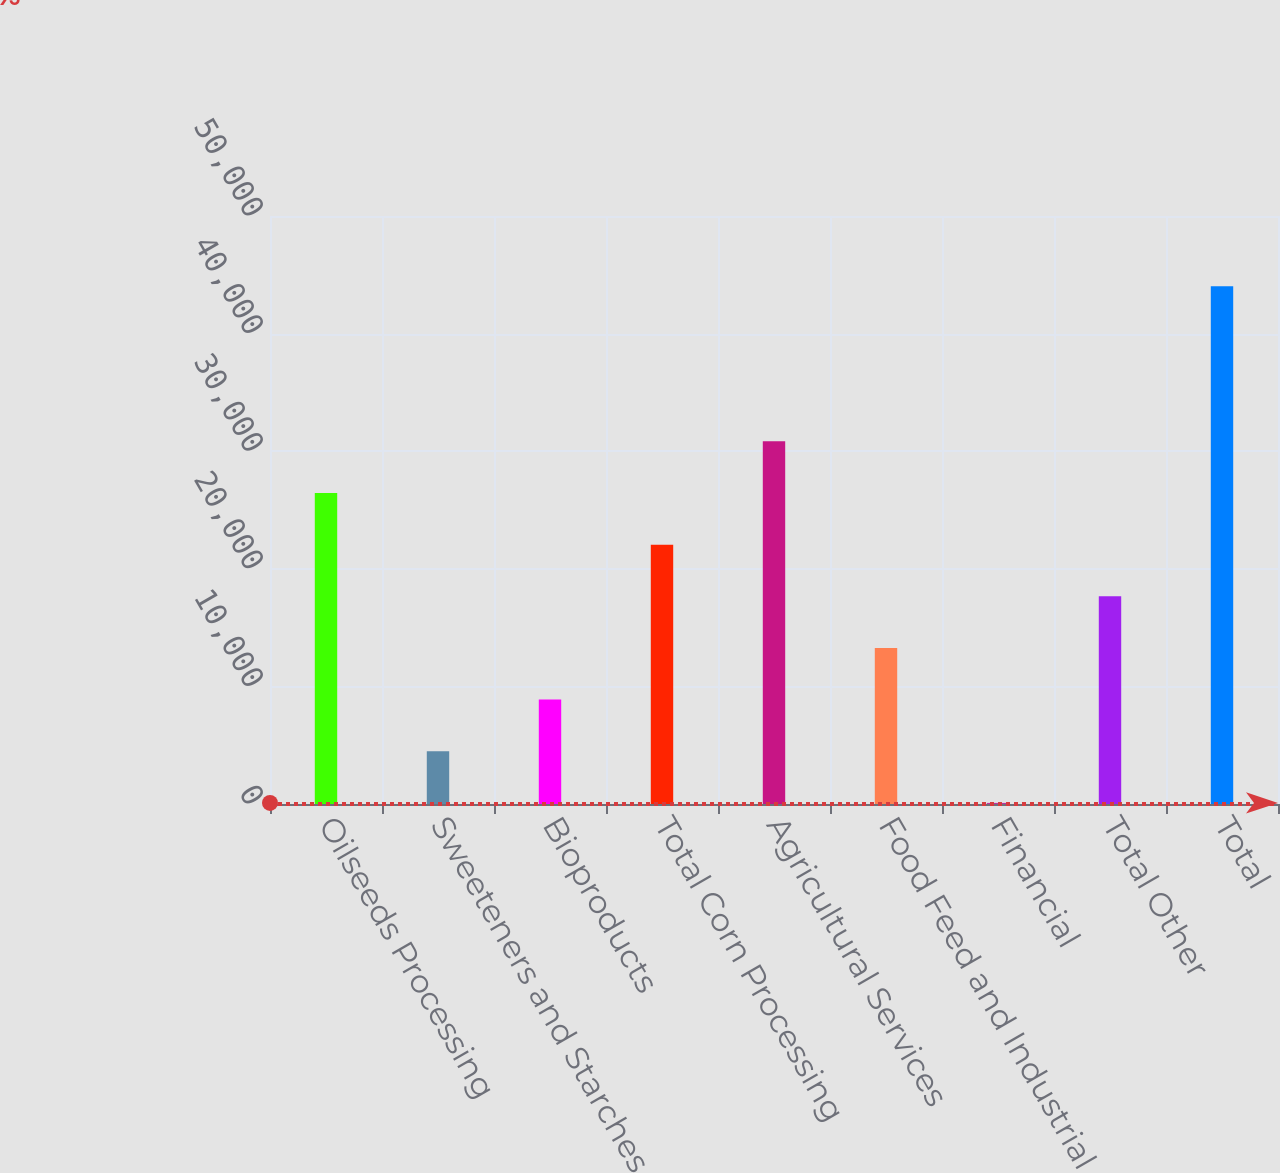Convert chart to OTSL. <chart><loc_0><loc_0><loc_500><loc_500><bar_chart><fcel>Oilseeds Processing<fcel>Sweeteners and Starches<fcel>Bioproducts<fcel>Total Corn Processing<fcel>Agricultural Services<fcel>Food Feed and Industrial<fcel>Financial<fcel>Total Other<fcel>Total<nl><fcel>26448<fcel>4485.5<fcel>8878<fcel>22055.5<fcel>30840.5<fcel>13270.5<fcel>93<fcel>17663<fcel>44018<nl></chart> 